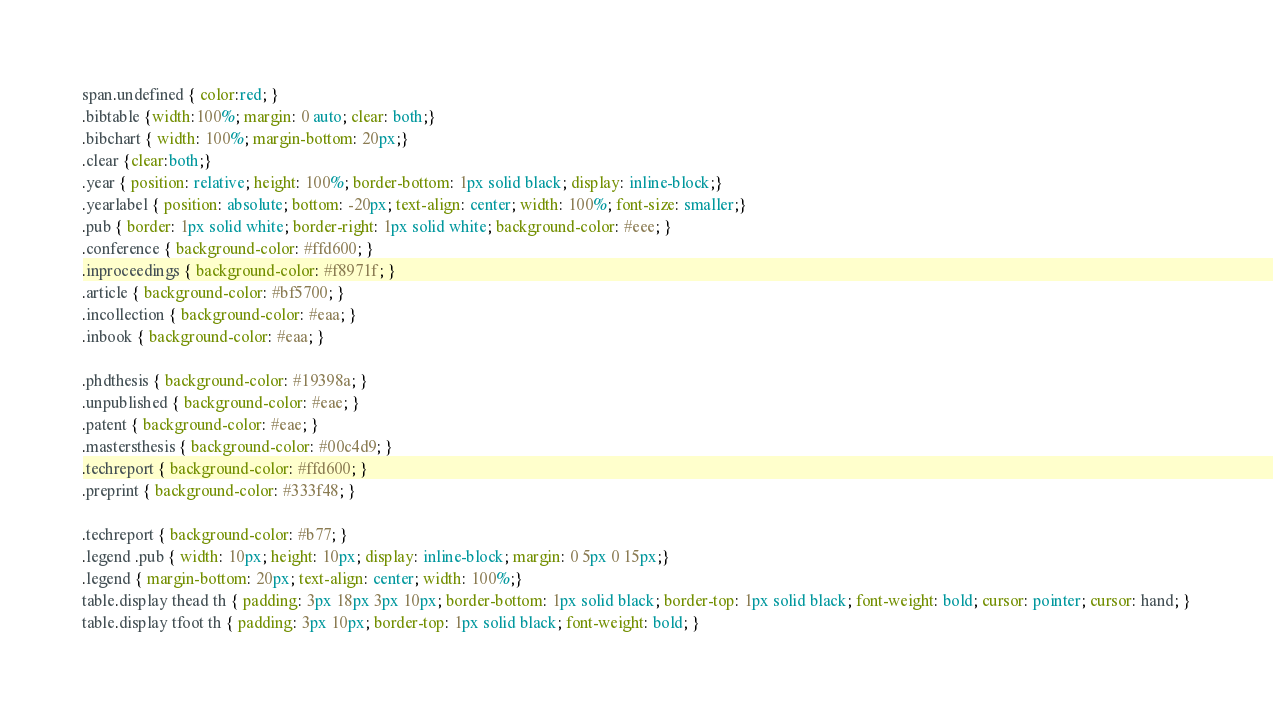Convert code to text. <code><loc_0><loc_0><loc_500><loc_500><_CSS_>span.undefined { color:red; }
.bibtable {width:100%; margin: 0 auto; clear: both;}
.bibchart { width: 100%; margin-bottom: 20px;}
.clear {clear:both;}
.year { position: relative; height: 100%; border-bottom: 1px solid black; display: inline-block;}
.yearlabel { position: absolute; bottom: -20px; text-align: center; width: 100%; font-size: smaller;}
.pub { border: 1px solid white; border-right: 1px solid white; background-color: #eee; }
.conference { background-color: #ffd600; }
.inproceedings { background-color: #f8971f; }
.article { background-color: #bf5700; }
.incollection { background-color: #eaa; }
.inbook { background-color: #eaa; }

.phdthesis { background-color: #19398a; }
.unpublished { background-color: #eae; }
.patent { background-color: #eae; }
.mastersthesis { background-color: #00c4d9; }
.techreport { background-color: #ffd600; }
.preprint { background-color: #333f48; }

.techreport { background-color: #b77; }
.legend .pub { width: 10px; height: 10px; display: inline-block; margin: 0 5px 0 15px;}
.legend { margin-bottom: 20px; text-align: center; width: 100%;}
table.display thead th { padding: 3px 18px 3px 10px; border-bottom: 1px solid black; border-top: 1px solid black; font-weight: bold; cursor: pointer; cursor: hand; }
table.display tfoot th { padding: 3px 10px; border-top: 1px solid black; font-weight: bold; }</code> 